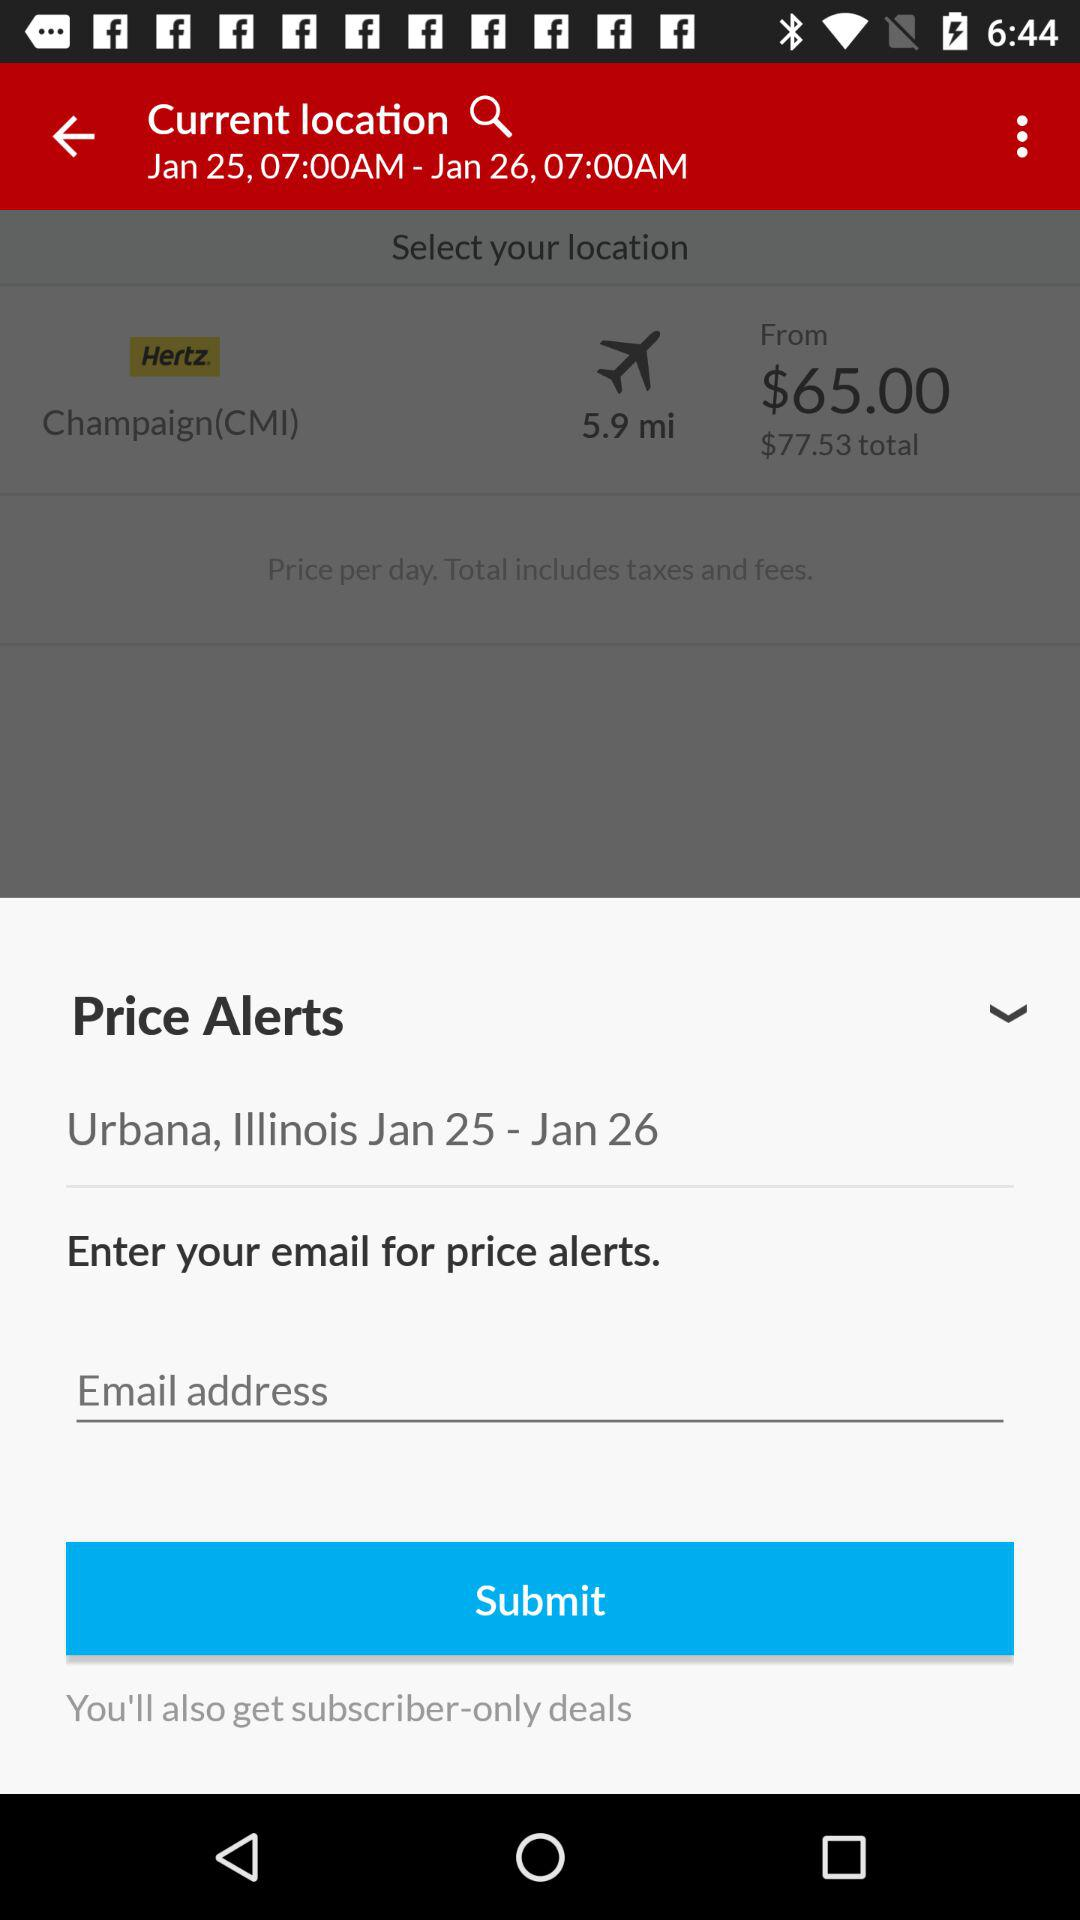How much is the total price of the rental?
Answer the question using a single word or phrase. $77.53 